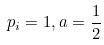Convert formula to latex. <formula><loc_0><loc_0><loc_500><loc_500>p _ { i } = 1 , a = \frac { 1 } { 2 }</formula> 